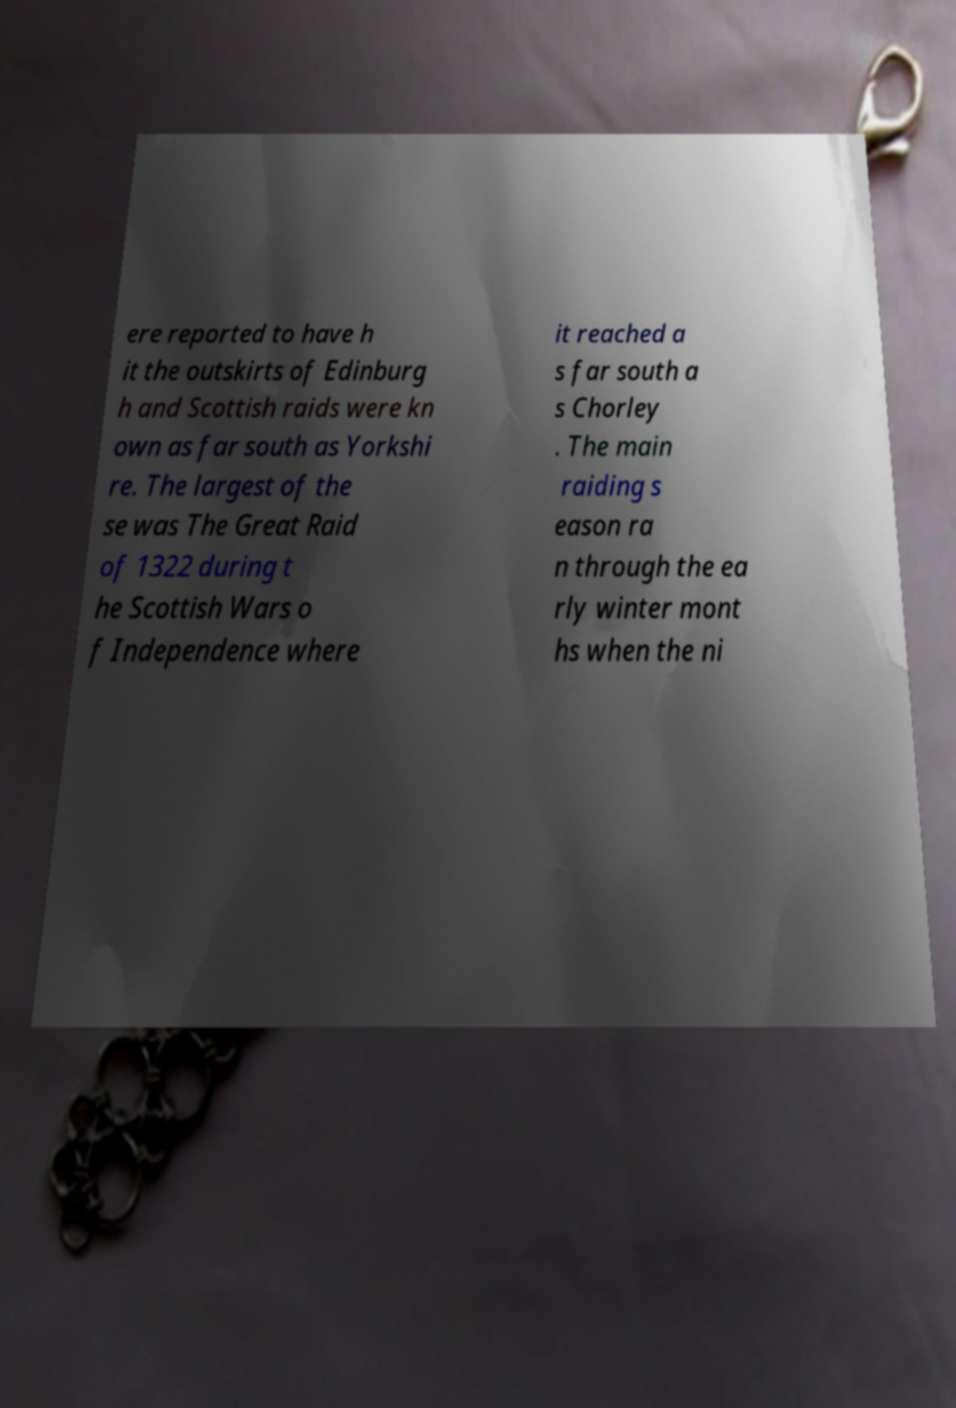There's text embedded in this image that I need extracted. Can you transcribe it verbatim? ere reported to have h it the outskirts of Edinburg h and Scottish raids were kn own as far south as Yorkshi re. The largest of the se was The Great Raid of 1322 during t he Scottish Wars o f Independence where it reached a s far south a s Chorley . The main raiding s eason ra n through the ea rly winter mont hs when the ni 